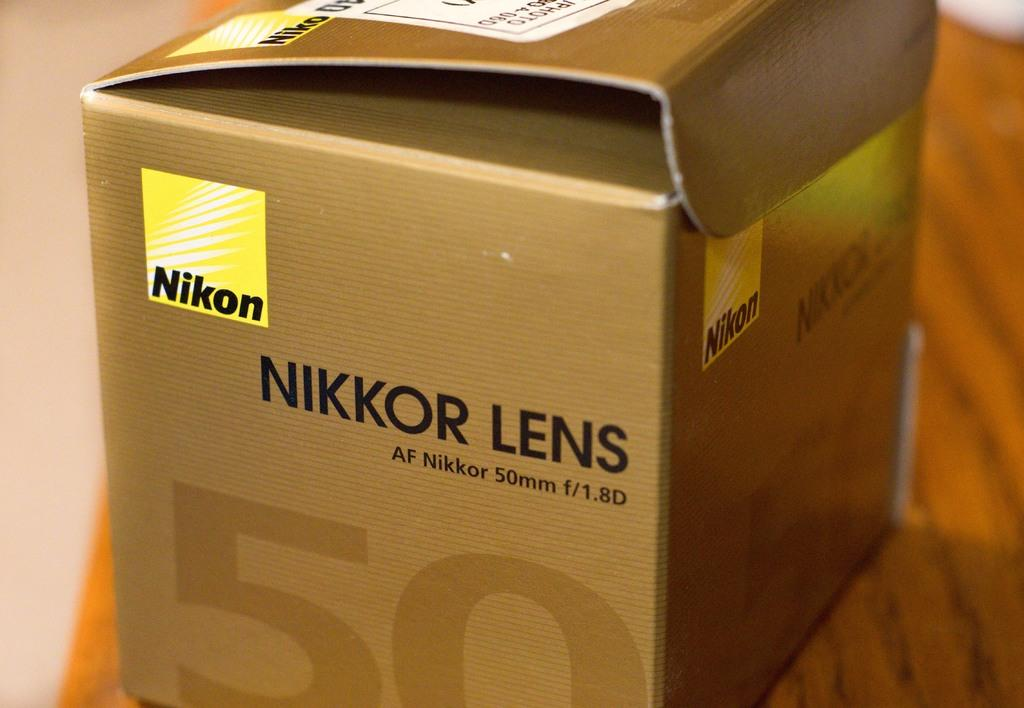<image>
Give a short and clear explanation of the subsequent image. A Nikon Nikkor lens af nikkor 50 mm f/1.8 d box. 